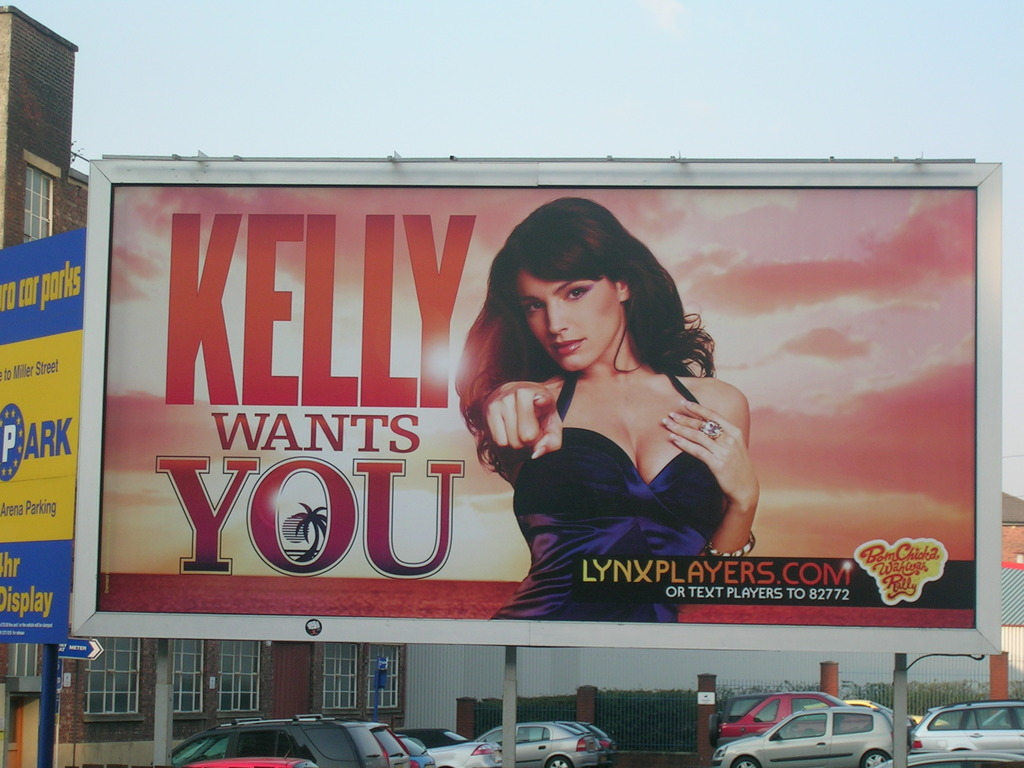Provide a one-sentence caption for the provided image. The billboard features a vibrant advertisement with the message 'Kelly Wants You', alongside a compelling portrait of a woman, promoting the website lynxplayers.com at the bottom right, set against a dramatic sky backdrop. 